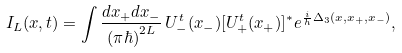<formula> <loc_0><loc_0><loc_500><loc_500>I _ { L } ( x , t ) = \int \frac { d x _ { + } d x _ { - } } { ( \pi \hbar { ) } ^ { 2 L } } \, U ^ { t } _ { - } ( x _ { - } ) [ U ^ { t } _ { + } ( x _ { + } ) ] ^ { * } e ^ { \frac { i } { h } \Delta _ { 3 } ( x , x _ { + } , x _ { - } ) } ,</formula> 